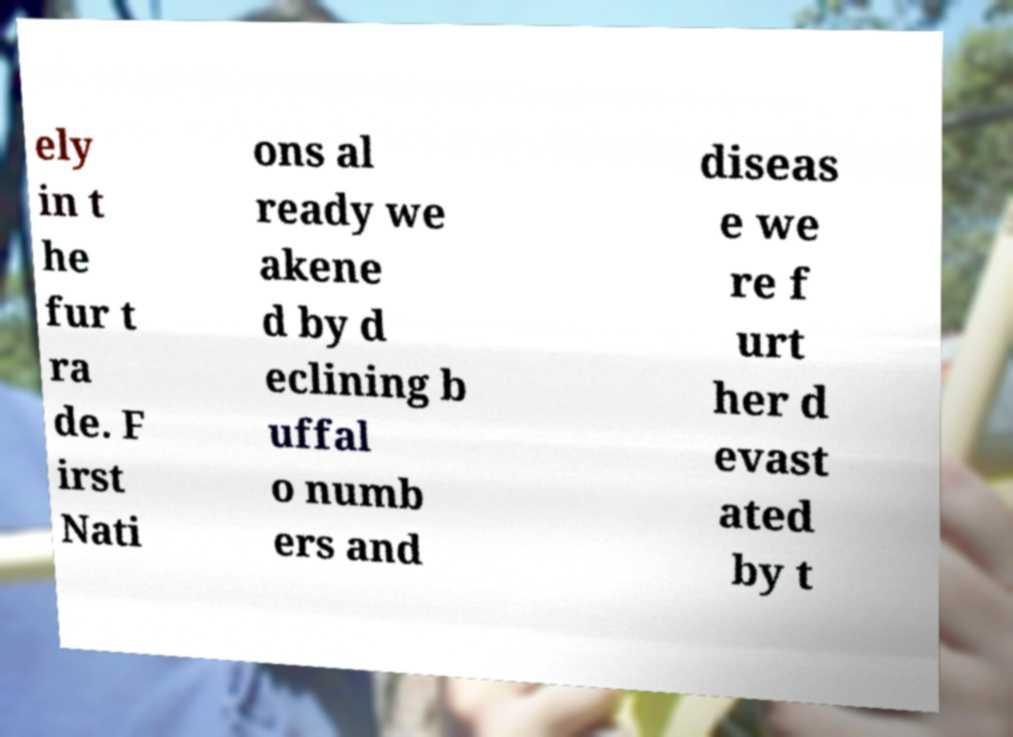Please read and relay the text visible in this image. What does it say? ely in t he fur t ra de. F irst Nati ons al ready we akene d by d eclining b uffal o numb ers and diseas e we re f urt her d evast ated by t 